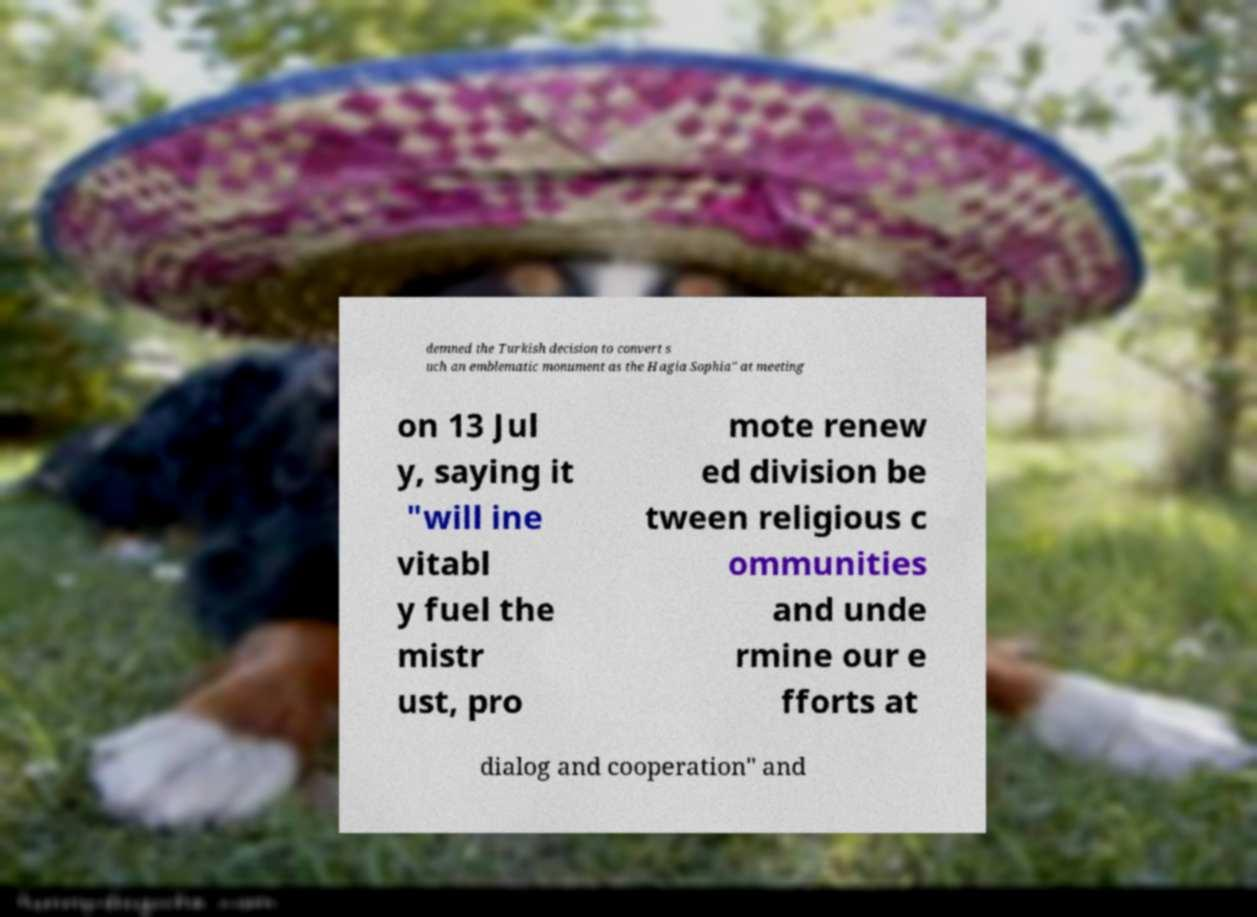Could you extract and type out the text from this image? demned the Turkish decision to convert s uch an emblematic monument as the Hagia Sophia" at meeting on 13 Jul y, saying it "will ine vitabl y fuel the mistr ust, pro mote renew ed division be tween religious c ommunities and unde rmine our e fforts at dialog and cooperation" and 